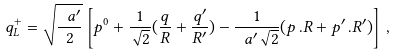Convert formula to latex. <formula><loc_0><loc_0><loc_500><loc_500>q ^ { + } _ { L } = \sqrt { \frac { \ a ^ { \prime } } { 2 } } \left [ p ^ { 0 } + \frac { 1 } { \sqrt { 2 } } ( \frac { q } { R } + \frac { q ^ { \prime } } { R ^ { \prime } } ) - { \frac { 1 } { \ a ^ { \prime } \sqrt { 2 } } ( p \, . R + p ^ { \prime } \, . R ^ { \prime } } ) \right ] \, ,</formula> 